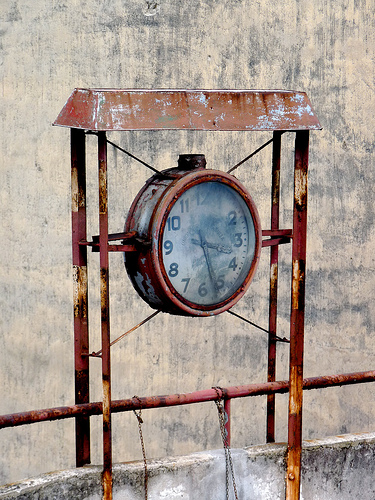Please provide a short description for this region: [0.24, 0.15, 0.77, 0.29]. Rusted metal housing surrounding the upper part of the clock. This cover shows significant weathering and contributes to the antique look of the clock. 